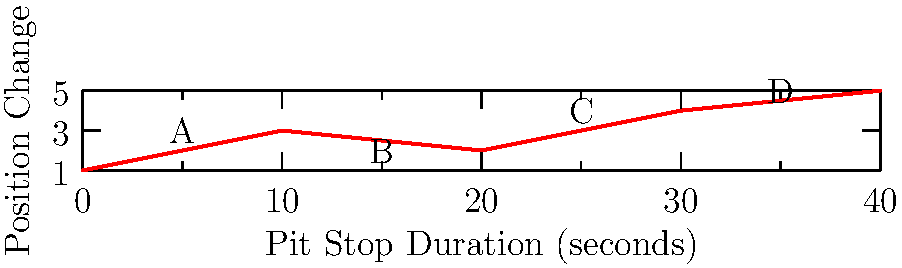Given the graph showing the relationship between pit stop duration and position change, and considering that competitors A, B, C, and D have different pit stop strategies, which competitor is most likely to gain positions if all drivers maintain consistent lap times? Assume that a lower y-axis value indicates a more favorable position change. To answer this question, we need to analyze the graph and interpret the relationship between pit stop duration and position change for each competitor:

1. First, note that a lower y-axis value indicates a more favorable position change (e.g., moving from 5th to 3rd place is represented by a y-value of 2).

2. Analyze each competitor's position on the graph:
   A: (5, 3) - 5-second pit stop, position change of 3
   B: (15, 2) - 15-second pit stop, position change of 2
   C: (25, 4) - 25-second pit stop, position change of 4
   D: (35, 5) - 35-second pit stop, position change of 5

3. Compare the position changes:
   B has the lowest y-value (2), indicating the most favorable position change.
   A is next with a y-value of 3.
   C and D have higher y-values, indicating less favorable position changes.

4. Consider the pit stop durations:
   B's 15-second pit stop is longer than A's 5-second stop, but results in a better position change.
   This suggests that B's strategy might be more effective (e.g., new tires, fuel strategy).

5. Assuming consistent lap times for all drivers, the position changes shown on the graph would be primarily due to pit stop strategy effectiveness.

Therefore, competitor B is most likely to gain positions, as their strategy results in the most favorable position change despite not having the shortest pit stop duration.
Answer: Competitor B 